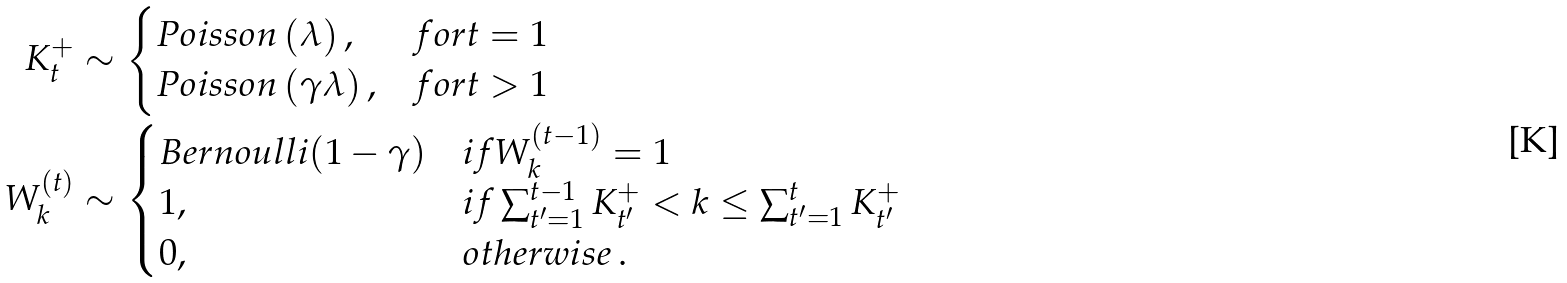<formula> <loc_0><loc_0><loc_500><loc_500>K _ { t } ^ { + } & \sim \begin{cases} P o i s s o n \left ( \lambda \right ) , & f o r t = 1 \\ P o i s s o n \left ( \gamma \lambda \right ) , & f o r t > 1 \end{cases} \\ W _ { k } ^ { ( t ) } & \sim \begin{cases} B e r n o u l l i ( 1 - \gamma ) & i f W _ { k } ^ { ( t - 1 ) } = 1 \\ 1 , & i f \sum _ { t ^ { \prime } = 1 } ^ { t - 1 } K _ { t ^ { \prime } } ^ { + } < k \leq \sum _ { t ^ { \prime } = 1 } ^ { t } K _ { t ^ { \prime } } ^ { + } \\ 0 , & o t h e r w i s e \, . \end{cases}</formula> 